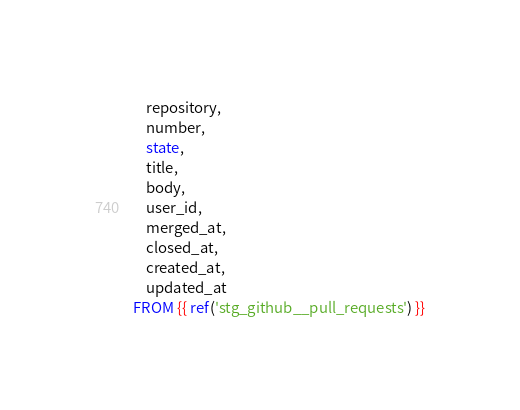<code> <loc_0><loc_0><loc_500><loc_500><_SQL_>    repository,
    number,
    state,
    title,
    body,
    user_id,
    merged_at,
    closed_at,
    created_at,
    updated_at
FROM {{ ref('stg_github__pull_requests') }}</code> 